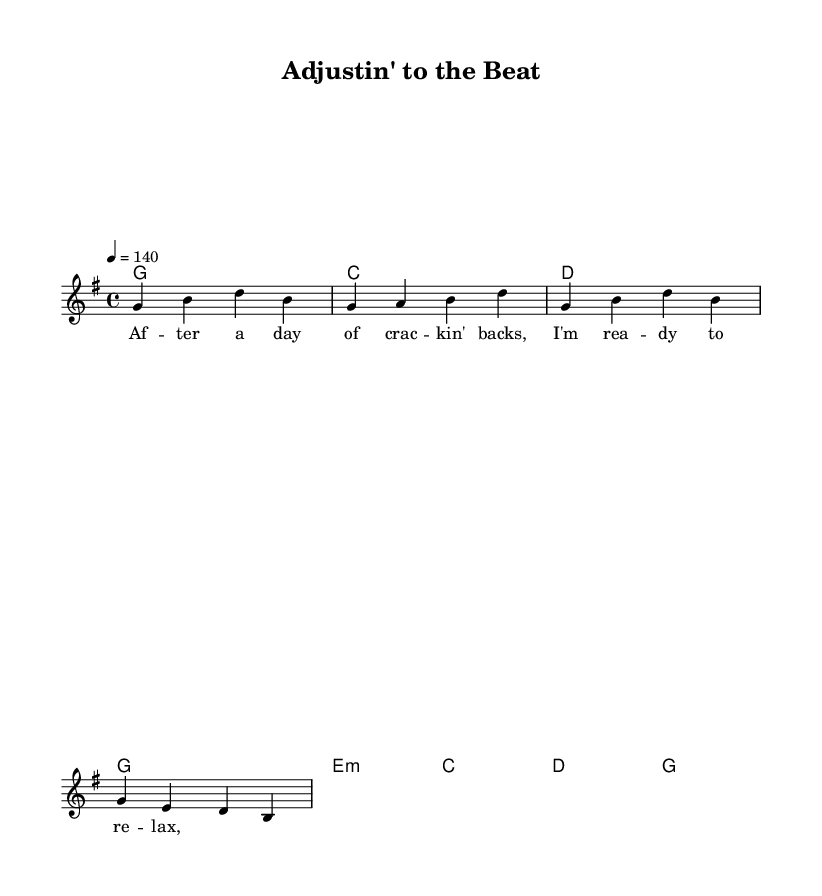What is the key signature of this music? The key signature shows one sharp, indicating that the piece is in G major.
Answer: G major What is the time signature of the piece? The time signature is indicated at the beginning of the score, showing that it is in a 4/4 meter.
Answer: 4/4 What is the tempo marking of this track? The tempo marking at the top indicates that the piece is set to 140 beats per minute, which is a lively pace.
Answer: 140 How many bars are in the melody section? By counting the measures in the melody, we find there are four bars in the melody section.
Answer: 4 bars What chord is played in the first measure? The chord specified at the beginning of the first measure is G major, which is noted in the harmonies part.
Answer: G What is the lyrical theme of the song? The lyrics provided describe the setting "After a day of crackin' backs, I'm ready to relax," suggesting a theme of unwinding after work.
Answer: Unwinding What type of musical genre does this piece belong to? The piece is characterized by a blend of country and rock elements, typical of the country rock genre, as seen in the style of the chords and rhythm.
Answer: Country rock 